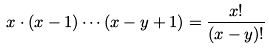<formula> <loc_0><loc_0><loc_500><loc_500>x \cdot ( x - 1 ) \cdots ( x - y + 1 ) = \frac { x ! } { ( x - y ) ! }</formula> 